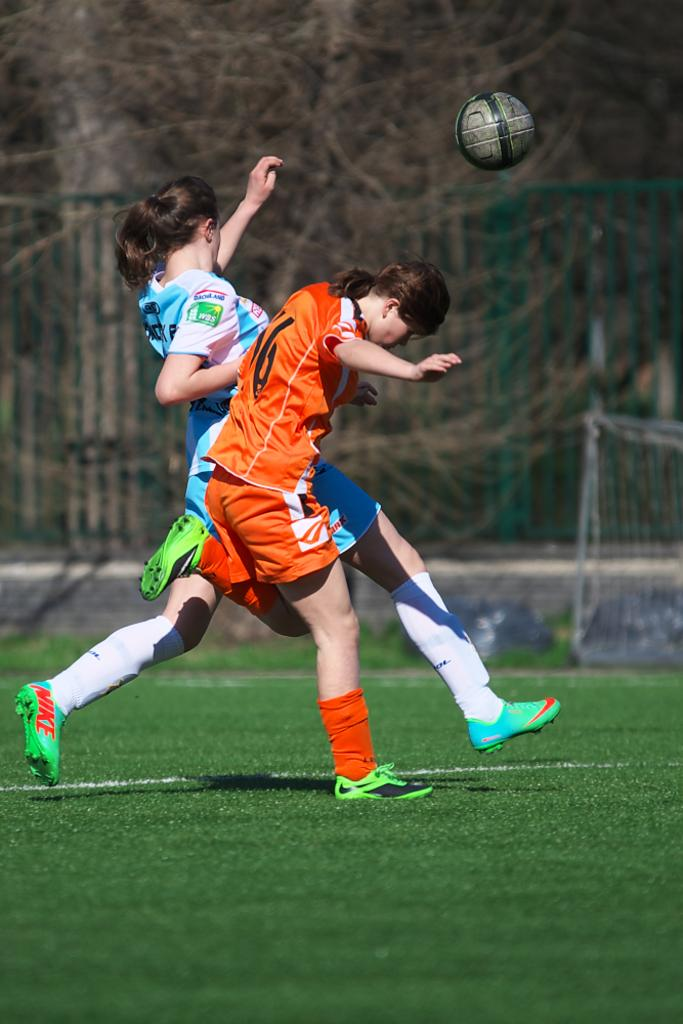What are the two persons in the image doing? The two persons in the image are running. What object is present in the image that is commonly used in sports? There is a ball in the image. What structure is visible in the image that is used to separate teams or players? There is a net in the image. What can be seen in the background of the image that indicates the location? There are iron grilles and trees in the background of the image. What historical event is depicted in the image? There is no historical event depicted in the image; it shows two persons running with a ball and a net in the background. 